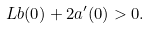Convert formula to latex. <formula><loc_0><loc_0><loc_500><loc_500>L b ( 0 ) + 2 a ^ { \prime } ( 0 ) > 0 .</formula> 